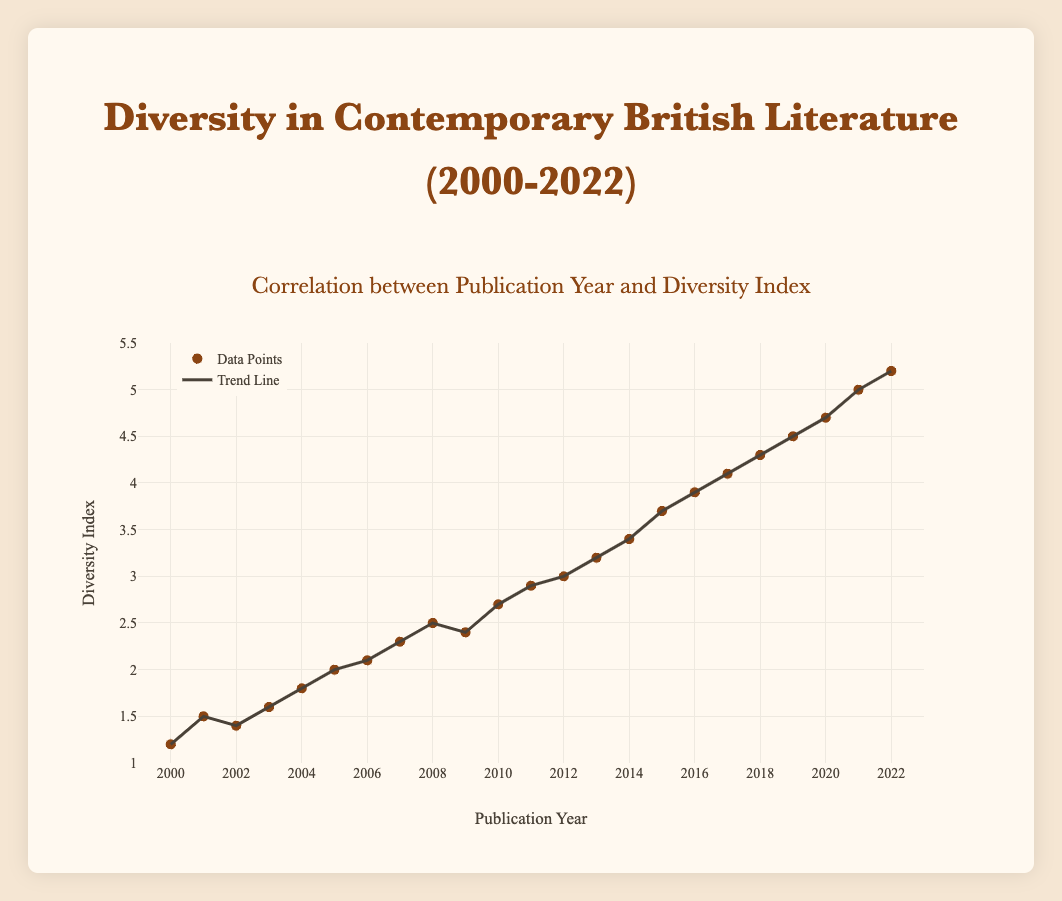What's the title of the plot? The title of the plot is displayed at the top of the figure. It reads "Correlation between Publication Year and Diversity Index."
Answer: Correlation between Publication Year and Diversity Index What is the range of years shown on the x-axis? The x-axis represents the publication year, with the range extending from 2000 to 2022. This is indicated by the axis labels and the tick marks along the x-axis.
Answer: 2000 to 2022 Which year has the highest diversity index value, and what is that value? By examining the data points and trend line, the point in 2022 has the highest diversity index value which is 5.2.
Answer: 2022, 5.2 Calculate the difference in the diversity index between the years 2000 and 2022. The diversity index in 2000 is 1.2, and in 2022 it is 5.2. The difference is calculated as 5.2 - 1.2 = 4.0.
Answer: 4.0 How many data points are plotted in the figure? By counting the markers, we can see that there are 23 data points plotted, one for each year from 2000 to 2022.
Answer: 23 What trend can you observe from the trend line in the scatter plot? The trend line shows an upward trajectory from 2000 to 2022, indicating that the diversity index in contemporary British literature has been increasing over time.
Answer: Increasing Which year shows a slight decrease in diversity index compared to its preceding year? By comparing the data points year by year, 2009 shows a slight decrease in the diversity index to 2.4 from 2.5 in 2008.
Answer: 2009 What is the diversity index value in the median year, and which year is it? To find the median year out of 23 years from 2000 to 2022, we find the 12th year which is 2011. The diversity index in 2011 is 2.9.
Answer: 2011, 2.9 